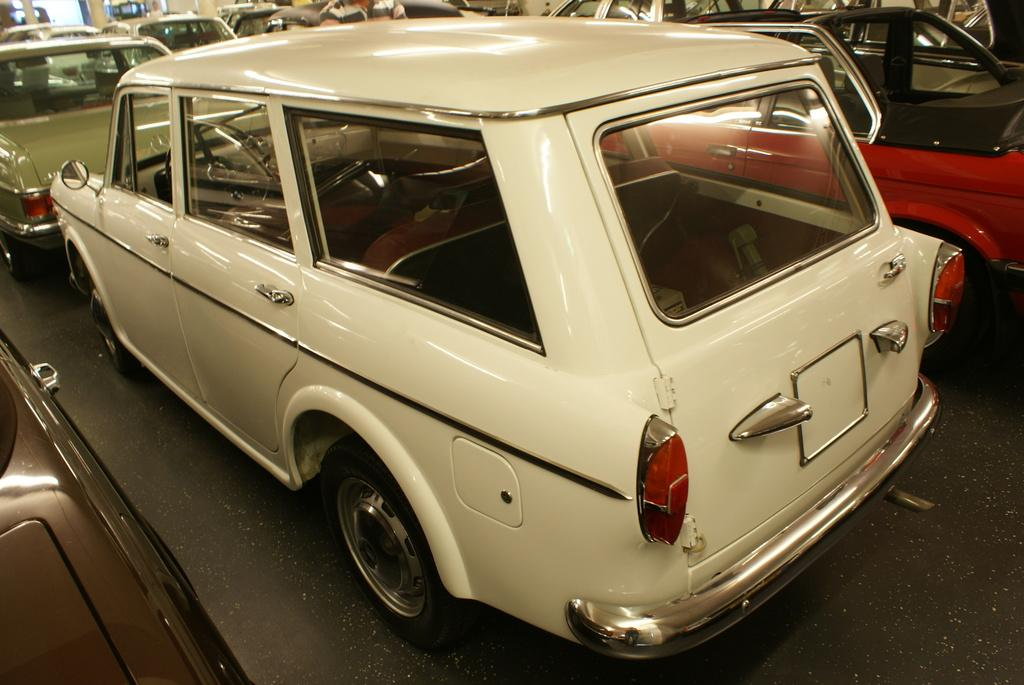What type of vehicles are in the image? There are cars in the image. Can you describe the white car in the image? The white car has tail lights, tyres, windows, handles, and mirrors. What color is the other car in the image? There is a red car in the image. What type of jeans is the driver of the red car wearing in the image? There is no information about the driver or their clothing in the image. What ornament is hanging from the rearview mirror of the white car? There is no ornament visible hanging from the rearview mirror of the white car in the image. 